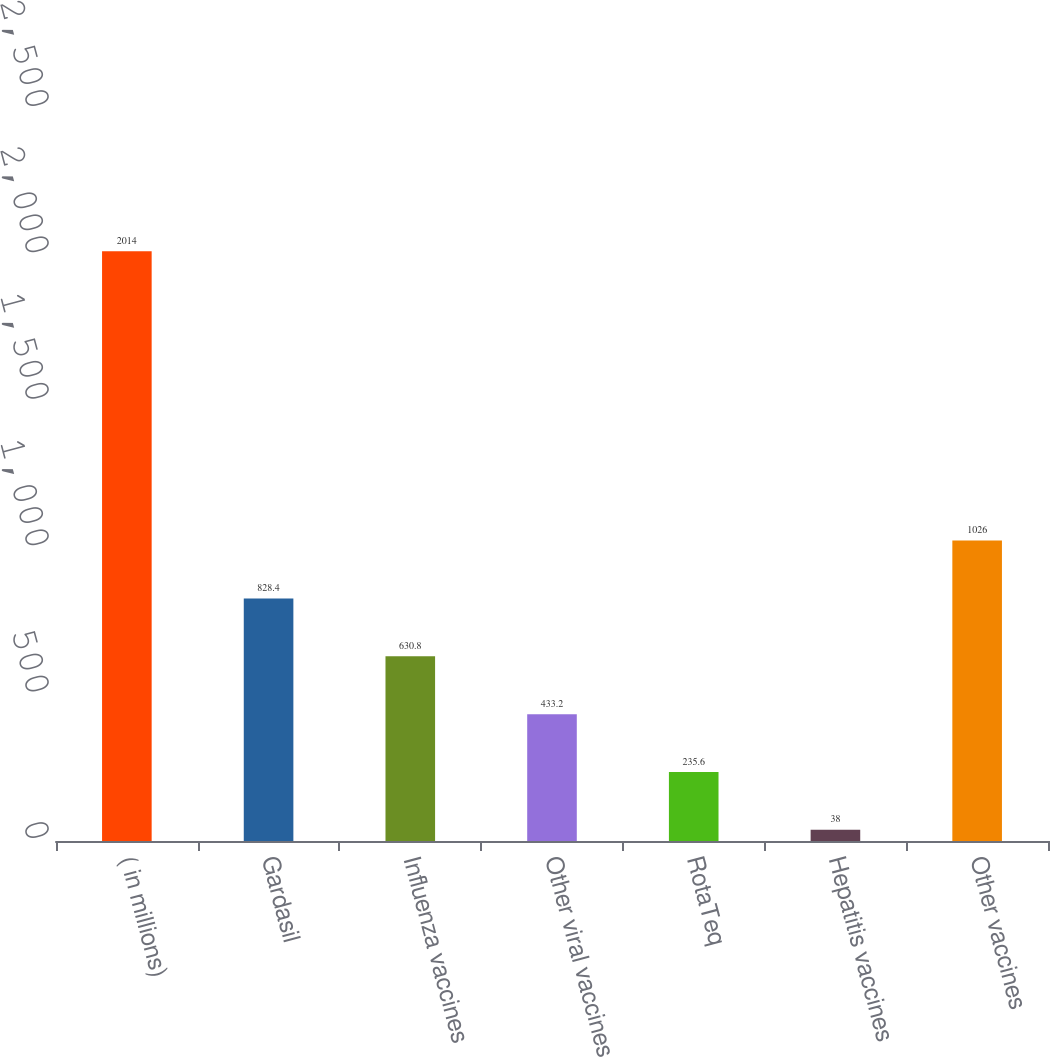Convert chart. <chart><loc_0><loc_0><loc_500><loc_500><bar_chart><fcel>( in millions)<fcel>Gardasil<fcel>Influenza vaccines<fcel>Other viral vaccines<fcel>RotaTeq<fcel>Hepatitis vaccines<fcel>Other vaccines<nl><fcel>2014<fcel>828.4<fcel>630.8<fcel>433.2<fcel>235.6<fcel>38<fcel>1026<nl></chart> 